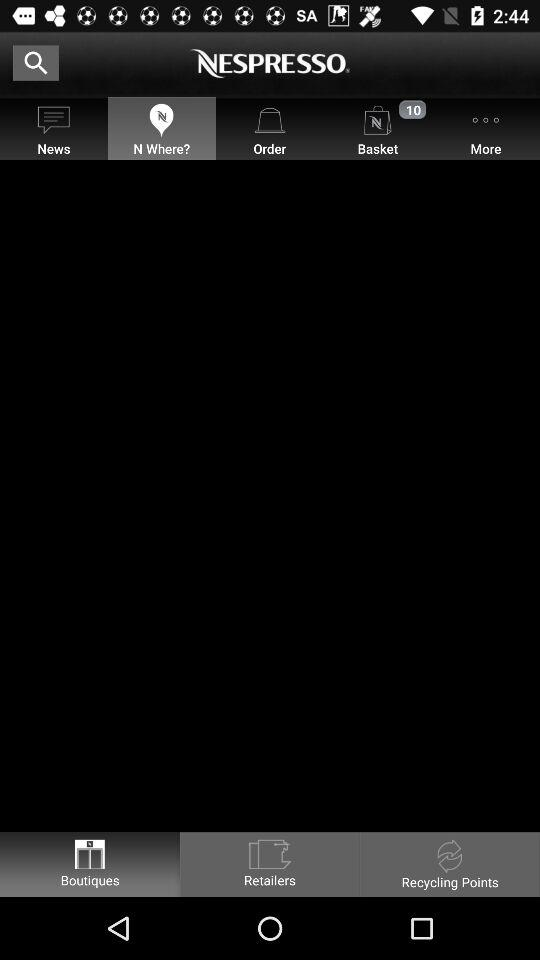How much has been ordered?
When the provided information is insufficient, respond with <no answer>. <no answer> 